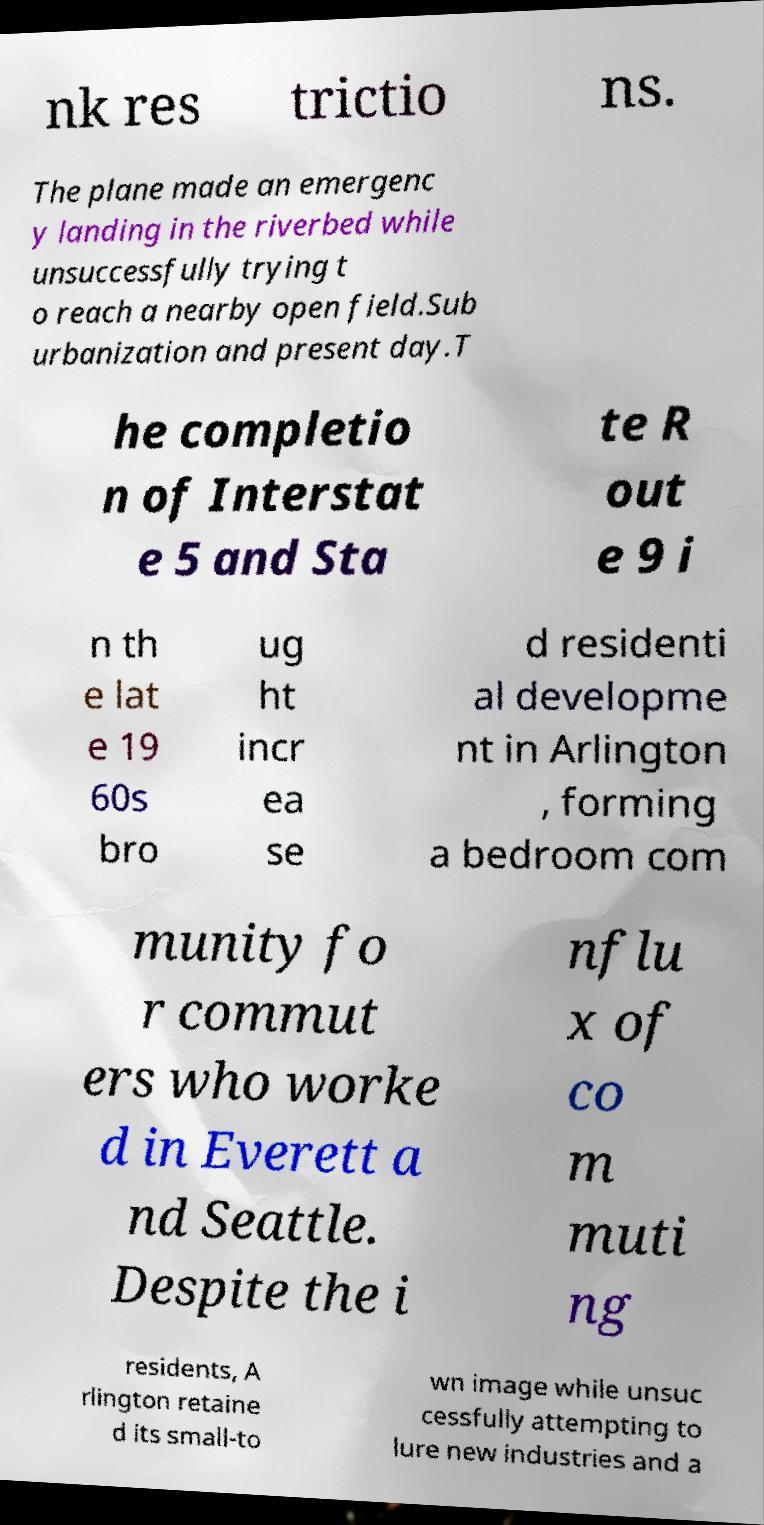I need the written content from this picture converted into text. Can you do that? nk res trictio ns. The plane made an emergenc y landing in the riverbed while unsuccessfully trying t o reach a nearby open field.Sub urbanization and present day.T he completio n of Interstat e 5 and Sta te R out e 9 i n th e lat e 19 60s bro ug ht incr ea se d residenti al developme nt in Arlington , forming a bedroom com munity fo r commut ers who worke d in Everett a nd Seattle. Despite the i nflu x of co m muti ng residents, A rlington retaine d its small-to wn image while unsuc cessfully attempting to lure new industries and a 